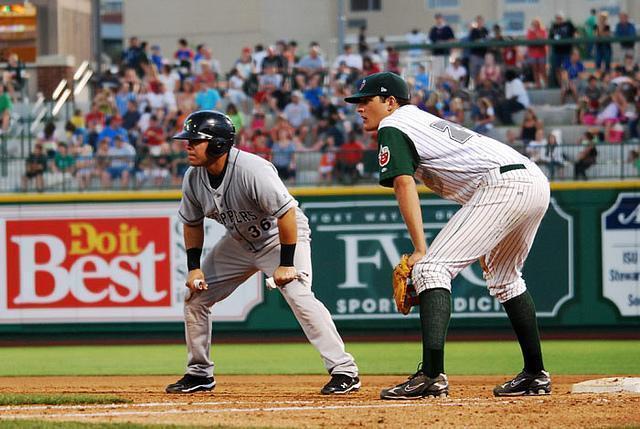How many people are visible?
Give a very brief answer. 3. 